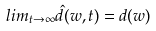<formula> <loc_0><loc_0><loc_500><loc_500>l i m _ { t \rightarrow \infty } \hat { d } ( w , t ) = d ( w )</formula> 